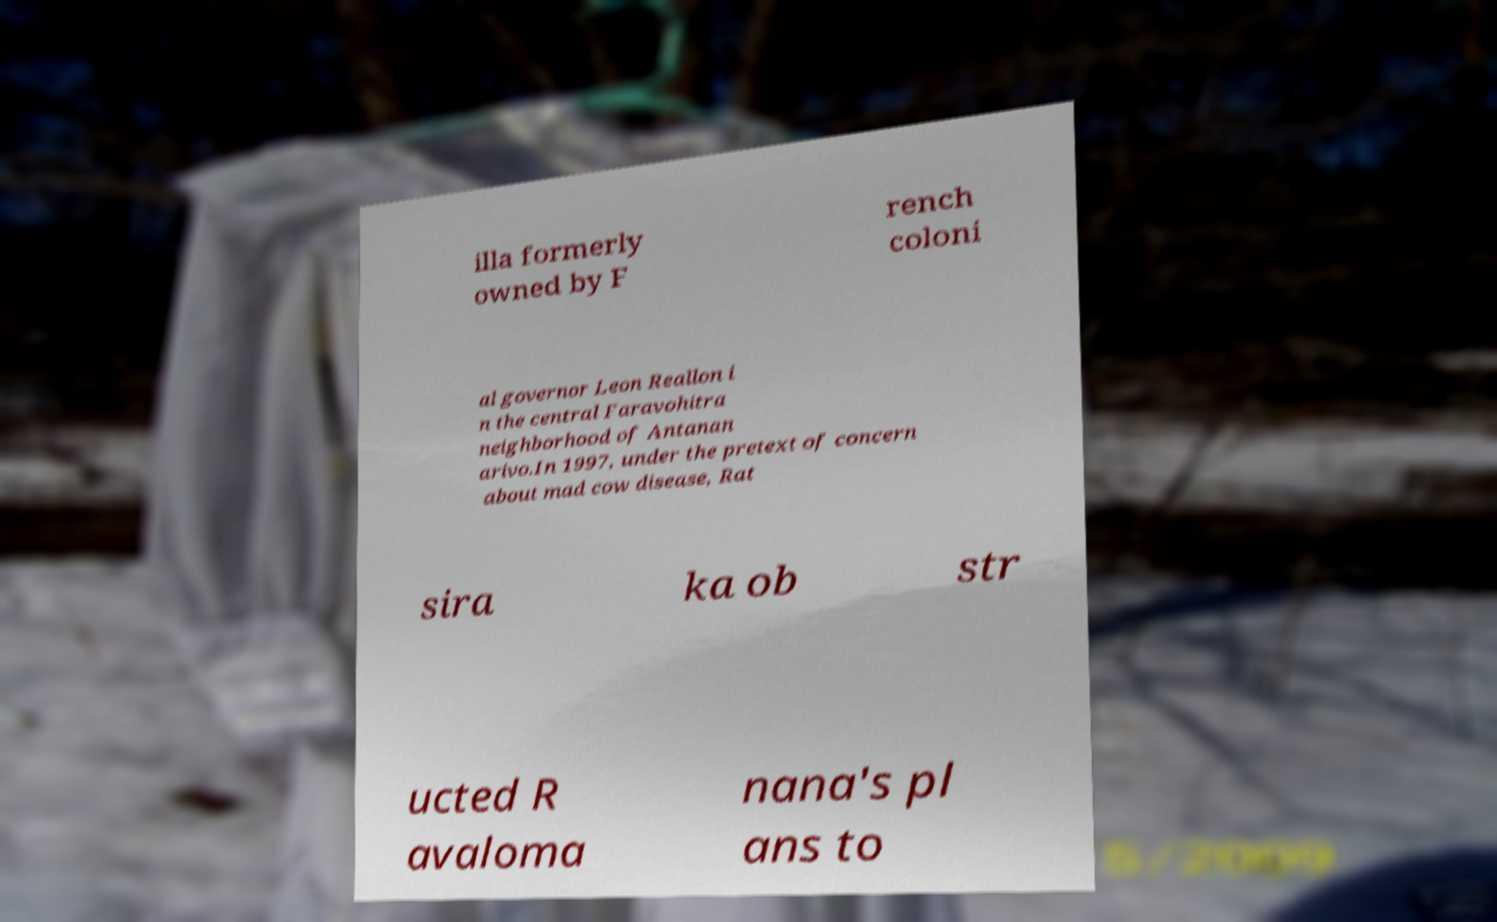For documentation purposes, I need the text within this image transcribed. Could you provide that? illa formerly owned by F rench coloni al governor Leon Reallon i n the central Faravohitra neighborhood of Antanan arivo.In 1997, under the pretext of concern about mad cow disease, Rat sira ka ob str ucted R avaloma nana's pl ans to 